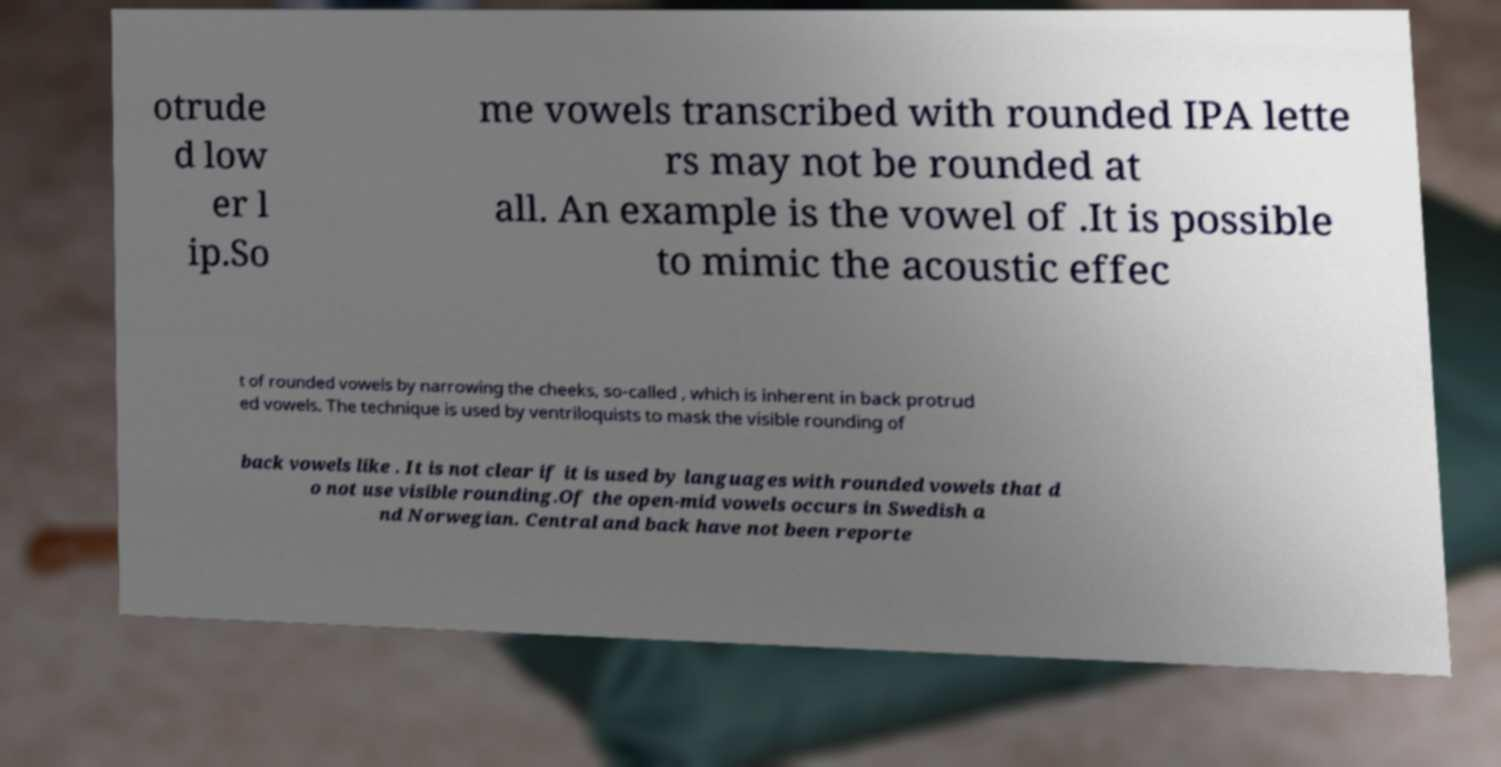Could you extract and type out the text from this image? otrude d low er l ip.So me vowels transcribed with rounded IPA lette rs may not be rounded at all. An example is the vowel of .It is possible to mimic the acoustic effec t of rounded vowels by narrowing the cheeks, so-called , which is inherent in back protrud ed vowels. The technique is used by ventriloquists to mask the visible rounding of back vowels like . It is not clear if it is used by languages with rounded vowels that d o not use visible rounding.Of the open-mid vowels occurs in Swedish a nd Norwegian. Central and back have not been reporte 